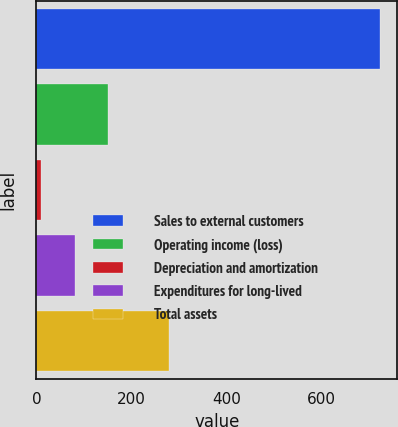<chart> <loc_0><loc_0><loc_500><loc_500><bar_chart><fcel>Sales to external customers<fcel>Operating income (loss)<fcel>Depreciation and amortization<fcel>Expenditures for long-lived<fcel>Total assets<nl><fcel>722.9<fcel>151.7<fcel>8.9<fcel>80.3<fcel>279.6<nl></chart> 